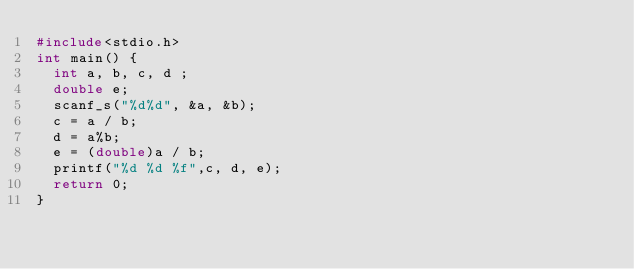<code> <loc_0><loc_0><loc_500><loc_500><_C_>#include<stdio.h>
int main() {
	int a, b, c, d ;
	double e;
	scanf_s("%d%d", &a, &b);
	c = a / b;
	d = a%b;
	e = (double)a / b;
	printf("%d %d %f",c, d, e);
	return 0;
}</code> 